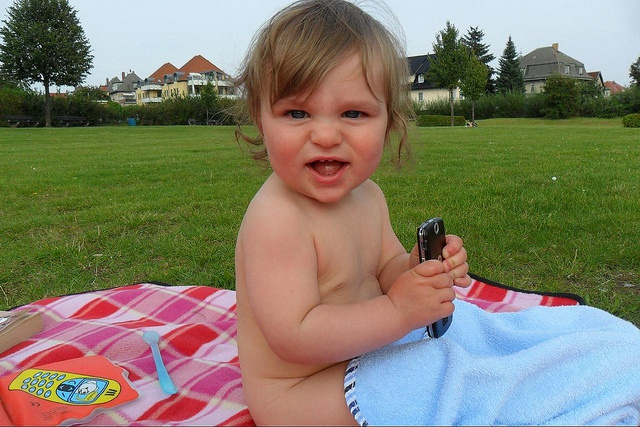Describe the objects in this image and their specific colors. I can see people in lightblue and salmon tones, cell phone in lightblue, black, gray, maroon, and darkgray tones, spoon in lightblue and darkgray tones, and cell phone in lightblue, darkblue, black, navy, and gray tones in this image. 